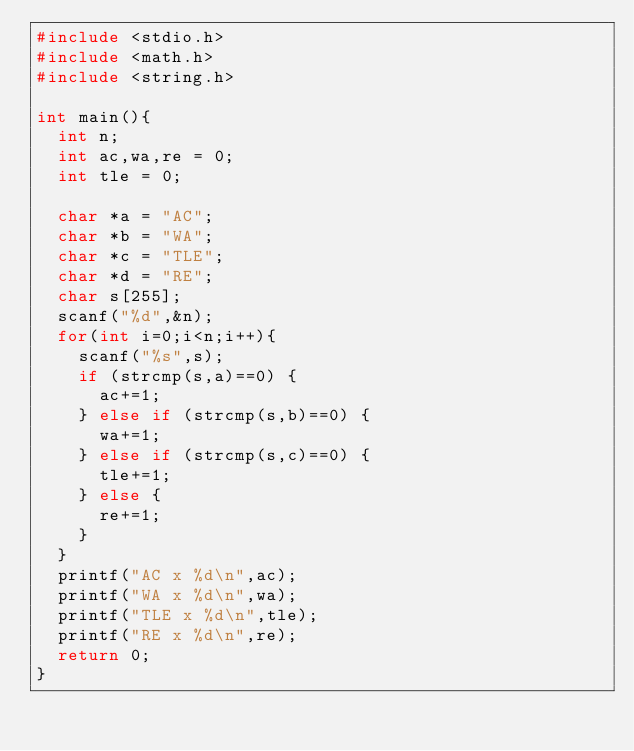Convert code to text. <code><loc_0><loc_0><loc_500><loc_500><_C_>#include <stdio.h>
#include <math.h>
#include <string.h>

int main(){
  int n;
  int ac,wa,re = 0;
  int tle = 0;
  
  char *a = "AC";
  char *b = "WA";
  char *c = "TLE";
  char *d = "RE";
  char s[255];
  scanf("%d",&n);
  for(int i=0;i<n;i++){
    scanf("%s",s);
    if (strcmp(s,a)==0) {
      ac+=1;
    } else if (strcmp(s,b)==0) {
      wa+=1;
    } else if (strcmp(s,c)==0) {
      tle+=1;
    } else {
      re+=1;
    }
  }
  printf("AC x %d\n",ac);
  printf("WA x %d\n",wa);
  printf("TLE x %d\n",tle);
  printf("RE x %d\n",re);
  return 0;
}
    </code> 